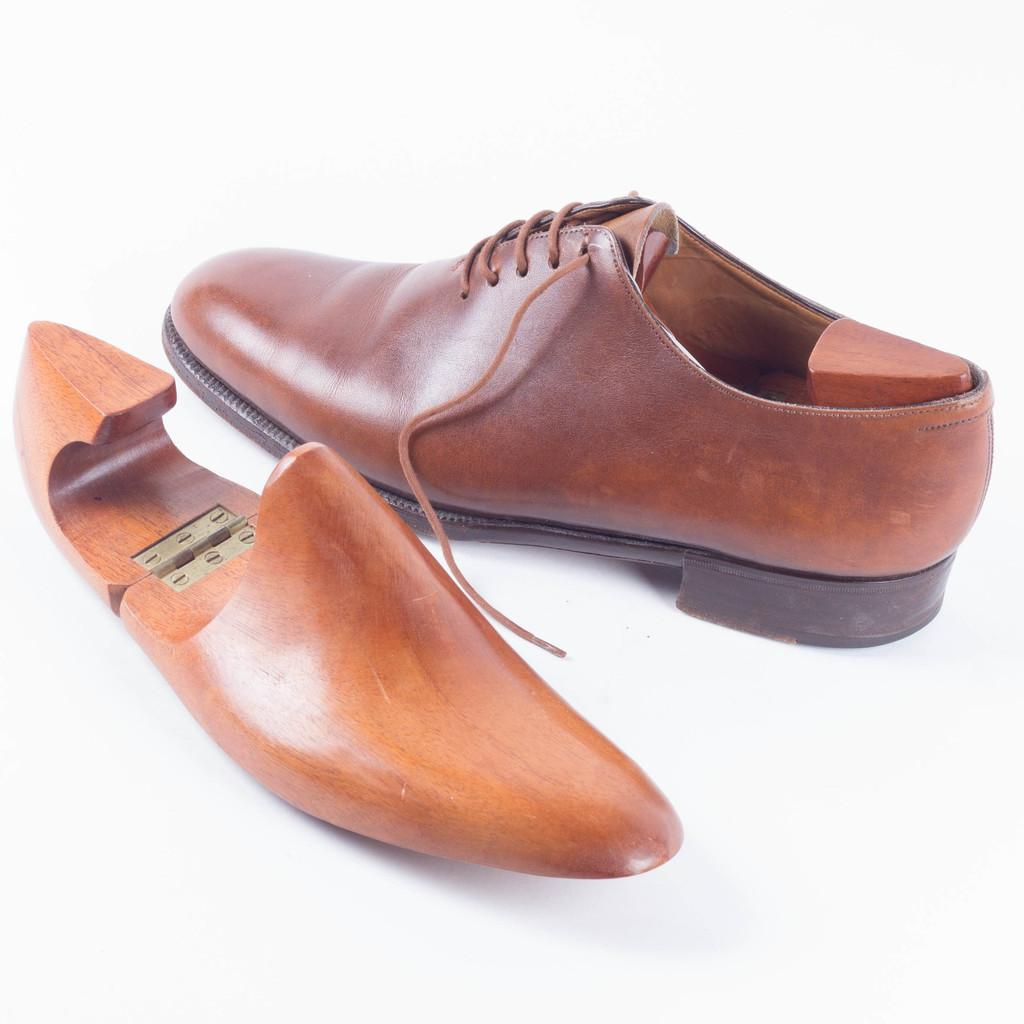What type of footwear is visible in the image? There is a pair of brown shoes in the image. What material is the wooden piece made of? The wooden piece in the image is made of wood. What color is the background of the image? The background of the image is white. What type of camera is being used to take the picture of the brown shoes? There is no camera visible in the image, so it cannot be determined what type of camera is being used to take the picture. 